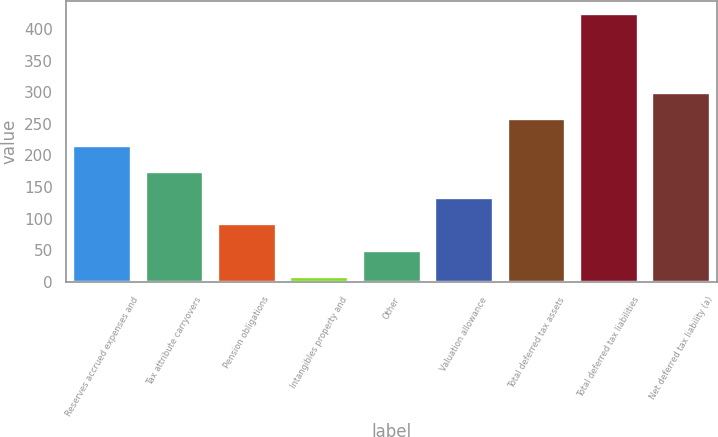<chart> <loc_0><loc_0><loc_500><loc_500><bar_chart><fcel>Reserves accrued expenses and<fcel>Tax attribute carryovers<fcel>Pension obligations<fcel>Intangibles property and<fcel>Other<fcel>Valuation allowance<fcel>Total deferred tax assets<fcel>Total deferred tax liabilities<fcel>Net deferred tax liability (a)<nl><fcel>215.65<fcel>174.1<fcel>91<fcel>7.9<fcel>49.45<fcel>132.55<fcel>257.2<fcel>423.4<fcel>298.75<nl></chart> 